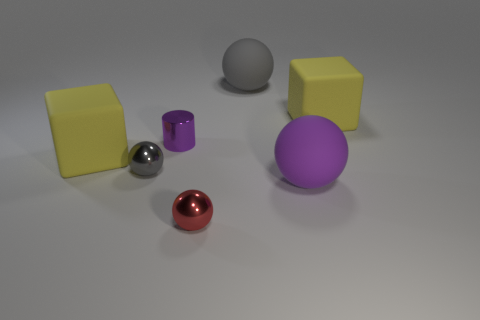The object that is behind the gray shiny thing and to the left of the purple metallic cylinder is made of what material?
Offer a very short reply. Rubber. What is the color of the small cylinder?
Ensure brevity in your answer.  Purple. How many other metal objects have the same shape as the small gray object?
Provide a short and direct response. 1. Are the yellow block on the right side of the purple metal thing and the tiny gray ball on the left side of the cylinder made of the same material?
Provide a short and direct response. No. There is a red metallic object that is on the left side of the cube on the right side of the big purple rubber thing; what is its size?
Provide a succinct answer. Small. There is a big purple thing that is the same shape as the gray metal thing; what is its material?
Give a very brief answer. Rubber. Do the large yellow thing to the right of the purple rubber thing and the large object that is left of the tiny gray metal thing have the same shape?
Offer a terse response. Yes. Are there more large gray objects than brown metallic cubes?
Offer a terse response. Yes. The gray matte object is what size?
Make the answer very short. Large. How many other things are the same color as the small cylinder?
Provide a succinct answer. 1. 